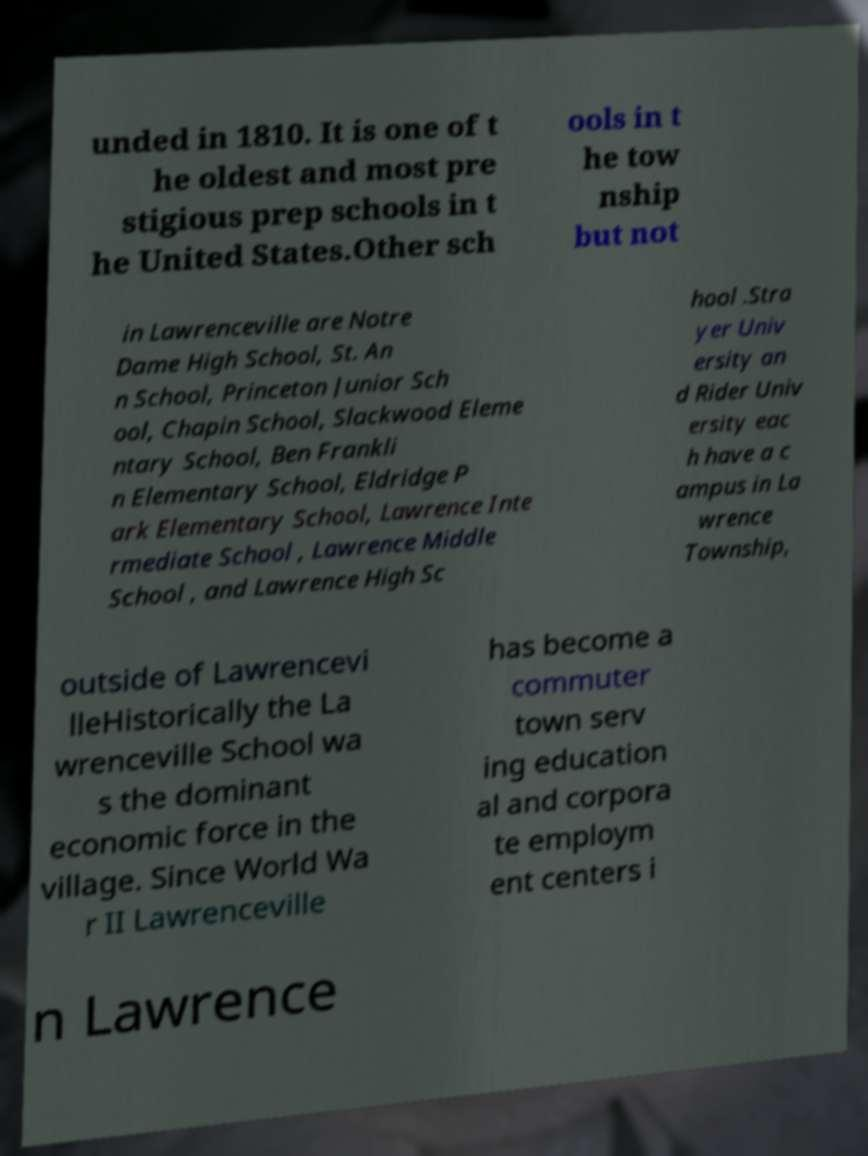I need the written content from this picture converted into text. Can you do that? unded in 1810. It is one of t he oldest and most pre stigious prep schools in t he United States.Other sch ools in t he tow nship but not in Lawrenceville are Notre Dame High School, St. An n School, Princeton Junior Sch ool, Chapin School, Slackwood Eleme ntary School, Ben Frankli n Elementary School, Eldridge P ark Elementary School, Lawrence Inte rmediate School , Lawrence Middle School , and Lawrence High Sc hool .Stra yer Univ ersity an d Rider Univ ersity eac h have a c ampus in La wrence Township, outside of Lawrencevi lleHistorically the La wrenceville School wa s the dominant economic force in the village. Since World Wa r II Lawrenceville has become a commuter town serv ing education al and corpora te employm ent centers i n Lawrence 